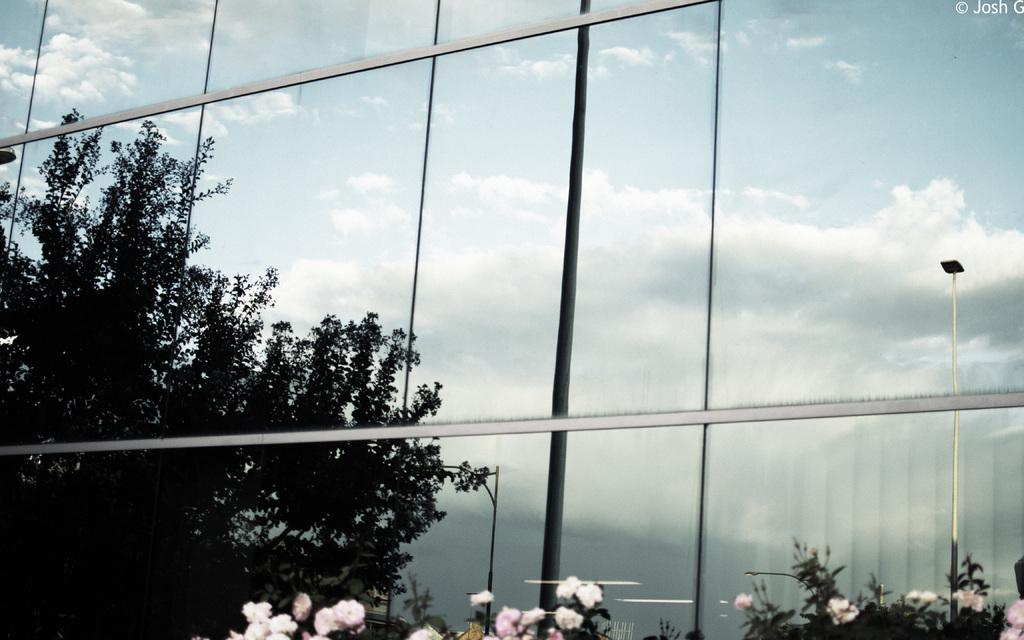What type of vegetation can be seen in the image? There are plants, flowers, and trees in the image. What structures are present in the image? There are poles and glass windows in the image. What can be seen in the background of the image? The sky is visible in the background of the image. Can you see any caves in the image? There are no caves present in the image. What type of pencil can be seen in the image? There is no pencil present in the image. 